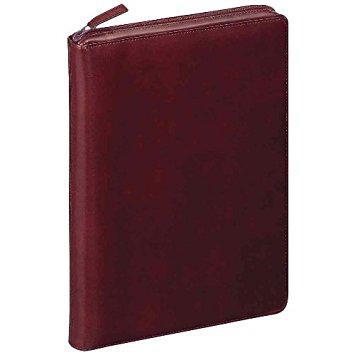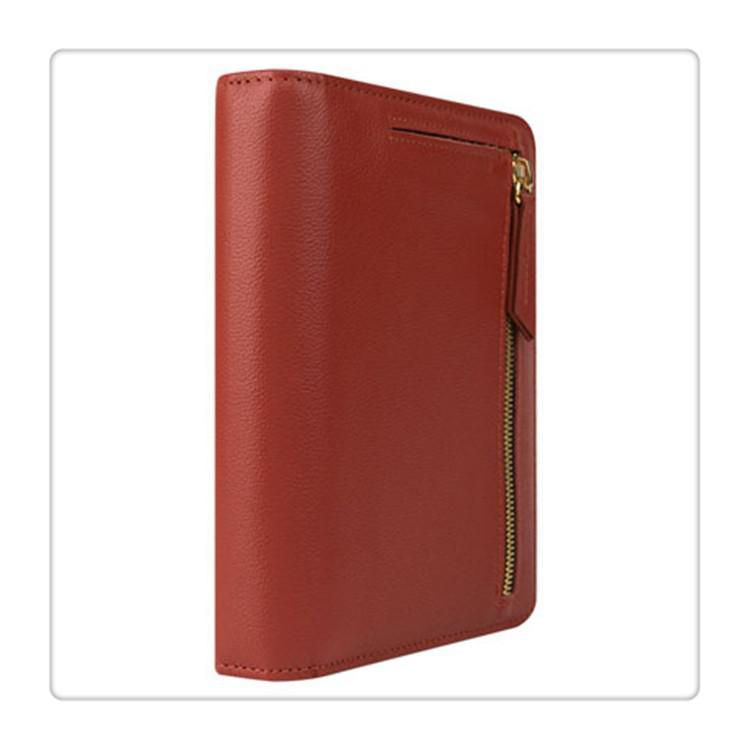The first image is the image on the left, the second image is the image on the right. Examine the images to the left and right. Is the description "In total, four binders are shown." accurate? Answer yes or no. No. 